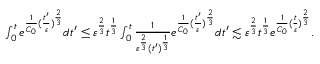Convert formula to latex. <formula><loc_0><loc_0><loc_500><loc_500>\begin{array} { r } { \int _ { 0 } ^ { t } e ^ { \frac { 1 } { C _ { 0 } } ( \frac { t ^ { \prime } } { \varepsilon } ) ^ { \frac { 2 } { 3 } } } d t ^ { \prime } \leq \varepsilon ^ { \frac { 2 } { 3 } } t ^ { \frac { 1 } { 3 } } \int _ { 0 } ^ { t } \frac { 1 } { \varepsilon ^ { \frac { 2 } { 3 } } ( t ^ { \prime } ) ^ { \frac { 1 } { 3 } } } e ^ { \frac { 1 } { C _ { 0 } } ( \frac { t ^ { \prime } } { \varepsilon } ) ^ { \frac { 2 } { 3 } } } d t ^ { \prime } \lesssim \varepsilon ^ { \frac { 2 } { 3 } } t ^ { \frac { 1 } { 3 } } e ^ { \frac { 1 } { C _ { 0 } } ( \frac { t } { \varepsilon } ) ^ { \frac { 2 } { 3 } } } . } \end{array}</formula> 